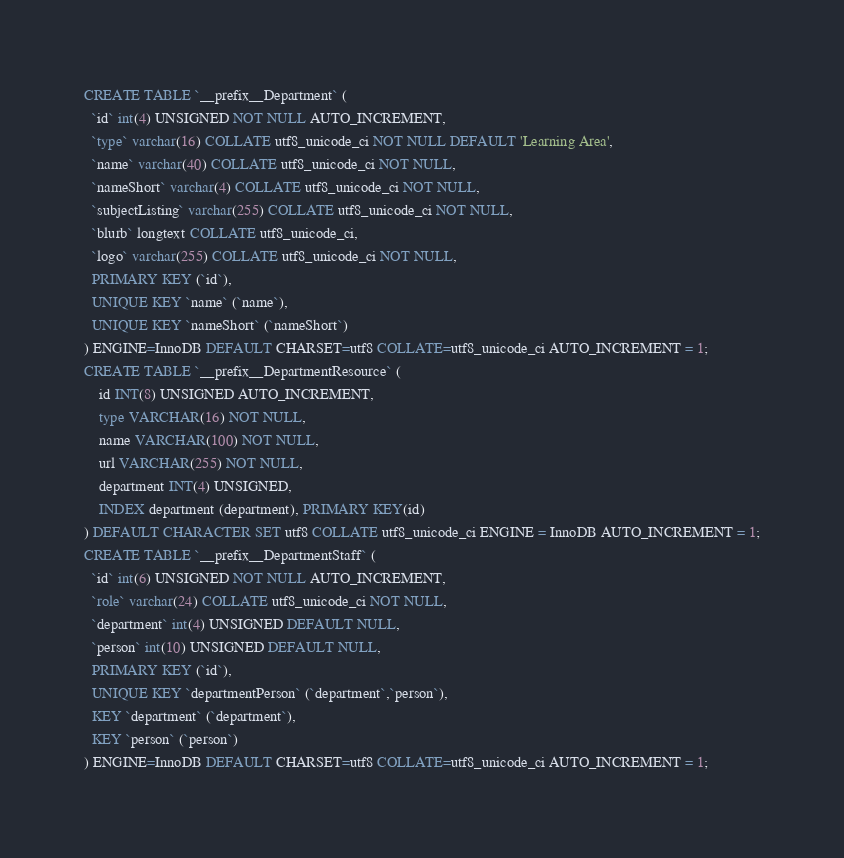<code> <loc_0><loc_0><loc_500><loc_500><_SQL_>CREATE TABLE `__prefix__Department` (
  `id` int(4) UNSIGNED NOT NULL AUTO_INCREMENT,
  `type` varchar(16) COLLATE utf8_unicode_ci NOT NULL DEFAULT 'Learning Area',
  `name` varchar(40) COLLATE utf8_unicode_ci NOT NULL,
  `nameShort` varchar(4) COLLATE utf8_unicode_ci NOT NULL,
  `subjectListing` varchar(255) COLLATE utf8_unicode_ci NOT NULL,
  `blurb` longtext COLLATE utf8_unicode_ci,
  `logo` varchar(255) COLLATE utf8_unicode_ci NOT NULL,
  PRIMARY KEY (`id`),
  UNIQUE KEY `name` (`name`),
  UNIQUE KEY `nameShort` (`nameShort`)
) ENGINE=InnoDB DEFAULT CHARSET=utf8 COLLATE=utf8_unicode_ci AUTO_INCREMENT = 1;
CREATE TABLE `__prefix__DepartmentResource` (
    id INT(8) UNSIGNED AUTO_INCREMENT,
    type VARCHAR(16) NOT NULL,
    name VARCHAR(100) NOT NULL,
    url VARCHAR(255) NOT NULL,
    department INT(4) UNSIGNED,
    INDEX department (department), PRIMARY KEY(id)
) DEFAULT CHARACTER SET utf8 COLLATE utf8_unicode_ci ENGINE = InnoDB AUTO_INCREMENT = 1;
CREATE TABLE `__prefix__DepartmentStaff` (
  `id` int(6) UNSIGNED NOT NULL AUTO_INCREMENT,
  `role` varchar(24) COLLATE utf8_unicode_ci NOT NULL,
  `department` int(4) UNSIGNED DEFAULT NULL,
  `person` int(10) UNSIGNED DEFAULT NULL,
  PRIMARY KEY (`id`),
  UNIQUE KEY `departmentPerson` (`department`,`person`),
  KEY `department` (`department`),
  KEY `person` (`person`)
) ENGINE=InnoDB DEFAULT CHARSET=utf8 COLLATE=utf8_unicode_ci AUTO_INCREMENT = 1;
</code> 